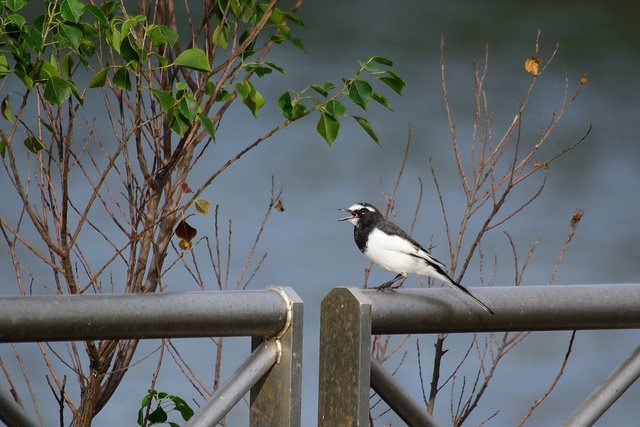Describe the objects in this image and their specific colors. I can see a bird in darkgreen, lightgray, black, darkgray, and gray tones in this image. 